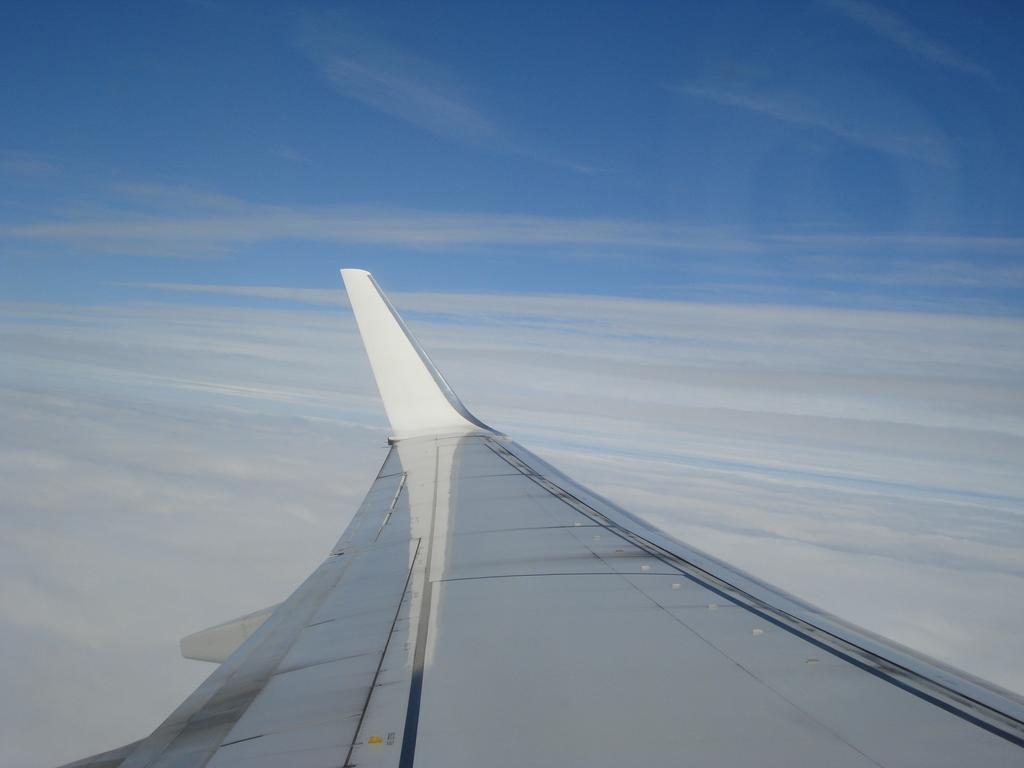What is the main subject of the image? The main subject of the image is a wing of an aeroplane. Where is the wing located in the image? The wing is in the sky. What type of foot injury is being treated in the hospital in the image? There is no hospital or foot injury present in the image; it features a wing of an aeroplane in the sky. 